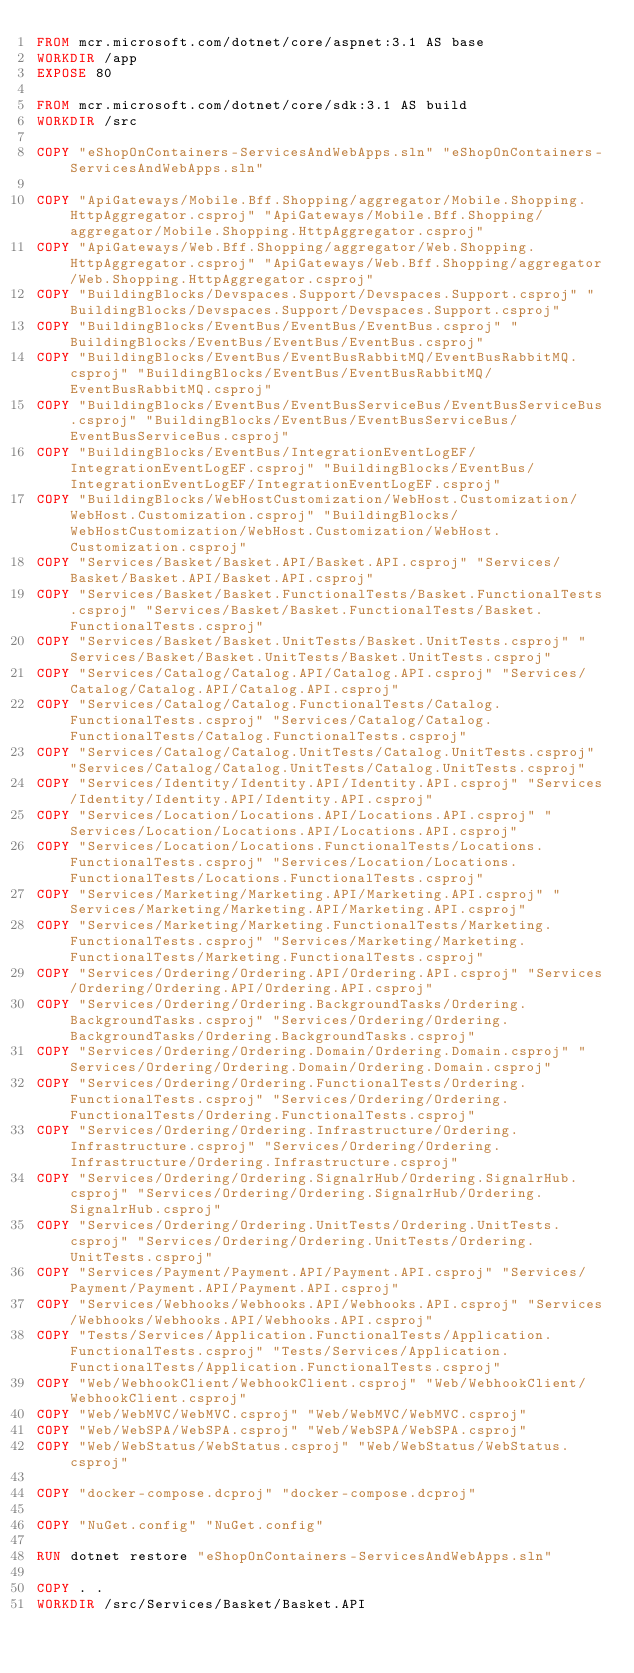Convert code to text. <code><loc_0><loc_0><loc_500><loc_500><_Dockerfile_>FROM mcr.microsoft.com/dotnet/core/aspnet:3.1 AS base
WORKDIR /app
EXPOSE 80

FROM mcr.microsoft.com/dotnet/core/sdk:3.1 AS build
WORKDIR /src

COPY "eShopOnContainers-ServicesAndWebApps.sln" "eShopOnContainers-ServicesAndWebApps.sln"

COPY "ApiGateways/Mobile.Bff.Shopping/aggregator/Mobile.Shopping.HttpAggregator.csproj" "ApiGateways/Mobile.Bff.Shopping/aggregator/Mobile.Shopping.HttpAggregator.csproj"
COPY "ApiGateways/Web.Bff.Shopping/aggregator/Web.Shopping.HttpAggregator.csproj" "ApiGateways/Web.Bff.Shopping/aggregator/Web.Shopping.HttpAggregator.csproj"
COPY "BuildingBlocks/Devspaces.Support/Devspaces.Support.csproj" "BuildingBlocks/Devspaces.Support/Devspaces.Support.csproj"
COPY "BuildingBlocks/EventBus/EventBus/EventBus.csproj" "BuildingBlocks/EventBus/EventBus/EventBus.csproj"
COPY "BuildingBlocks/EventBus/EventBusRabbitMQ/EventBusRabbitMQ.csproj" "BuildingBlocks/EventBus/EventBusRabbitMQ/EventBusRabbitMQ.csproj"
COPY "BuildingBlocks/EventBus/EventBusServiceBus/EventBusServiceBus.csproj" "BuildingBlocks/EventBus/EventBusServiceBus/EventBusServiceBus.csproj"
COPY "BuildingBlocks/EventBus/IntegrationEventLogEF/IntegrationEventLogEF.csproj" "BuildingBlocks/EventBus/IntegrationEventLogEF/IntegrationEventLogEF.csproj"
COPY "BuildingBlocks/WebHostCustomization/WebHost.Customization/WebHost.Customization.csproj" "BuildingBlocks/WebHostCustomization/WebHost.Customization/WebHost.Customization.csproj"
COPY "Services/Basket/Basket.API/Basket.API.csproj" "Services/Basket/Basket.API/Basket.API.csproj"
COPY "Services/Basket/Basket.FunctionalTests/Basket.FunctionalTests.csproj" "Services/Basket/Basket.FunctionalTests/Basket.FunctionalTests.csproj"
COPY "Services/Basket/Basket.UnitTests/Basket.UnitTests.csproj" "Services/Basket/Basket.UnitTests/Basket.UnitTests.csproj"
COPY "Services/Catalog/Catalog.API/Catalog.API.csproj" "Services/Catalog/Catalog.API/Catalog.API.csproj"
COPY "Services/Catalog/Catalog.FunctionalTests/Catalog.FunctionalTests.csproj" "Services/Catalog/Catalog.FunctionalTests/Catalog.FunctionalTests.csproj"
COPY "Services/Catalog/Catalog.UnitTests/Catalog.UnitTests.csproj" "Services/Catalog/Catalog.UnitTests/Catalog.UnitTests.csproj"
COPY "Services/Identity/Identity.API/Identity.API.csproj" "Services/Identity/Identity.API/Identity.API.csproj"
COPY "Services/Location/Locations.API/Locations.API.csproj" "Services/Location/Locations.API/Locations.API.csproj"
COPY "Services/Location/Locations.FunctionalTests/Locations.FunctionalTests.csproj" "Services/Location/Locations.FunctionalTests/Locations.FunctionalTests.csproj"
COPY "Services/Marketing/Marketing.API/Marketing.API.csproj" "Services/Marketing/Marketing.API/Marketing.API.csproj"
COPY "Services/Marketing/Marketing.FunctionalTests/Marketing.FunctionalTests.csproj" "Services/Marketing/Marketing.FunctionalTests/Marketing.FunctionalTests.csproj"
COPY "Services/Ordering/Ordering.API/Ordering.API.csproj" "Services/Ordering/Ordering.API/Ordering.API.csproj"
COPY "Services/Ordering/Ordering.BackgroundTasks/Ordering.BackgroundTasks.csproj" "Services/Ordering/Ordering.BackgroundTasks/Ordering.BackgroundTasks.csproj"
COPY "Services/Ordering/Ordering.Domain/Ordering.Domain.csproj" "Services/Ordering/Ordering.Domain/Ordering.Domain.csproj"
COPY "Services/Ordering/Ordering.FunctionalTests/Ordering.FunctionalTests.csproj" "Services/Ordering/Ordering.FunctionalTests/Ordering.FunctionalTests.csproj"
COPY "Services/Ordering/Ordering.Infrastructure/Ordering.Infrastructure.csproj" "Services/Ordering/Ordering.Infrastructure/Ordering.Infrastructure.csproj"
COPY "Services/Ordering/Ordering.SignalrHub/Ordering.SignalrHub.csproj" "Services/Ordering/Ordering.SignalrHub/Ordering.SignalrHub.csproj"
COPY "Services/Ordering/Ordering.UnitTests/Ordering.UnitTests.csproj" "Services/Ordering/Ordering.UnitTests/Ordering.UnitTests.csproj"
COPY "Services/Payment/Payment.API/Payment.API.csproj" "Services/Payment/Payment.API/Payment.API.csproj"
COPY "Services/Webhooks/Webhooks.API/Webhooks.API.csproj" "Services/Webhooks/Webhooks.API/Webhooks.API.csproj"
COPY "Tests/Services/Application.FunctionalTests/Application.FunctionalTests.csproj" "Tests/Services/Application.FunctionalTests/Application.FunctionalTests.csproj"
COPY "Web/WebhookClient/WebhookClient.csproj" "Web/WebhookClient/WebhookClient.csproj"
COPY "Web/WebMVC/WebMVC.csproj" "Web/WebMVC/WebMVC.csproj"
COPY "Web/WebSPA/WebSPA.csproj" "Web/WebSPA/WebSPA.csproj"
COPY "Web/WebStatus/WebStatus.csproj" "Web/WebStatus/WebStatus.csproj"

COPY "docker-compose.dcproj" "docker-compose.dcproj"

COPY "NuGet.config" "NuGet.config"

RUN dotnet restore "eShopOnContainers-ServicesAndWebApps.sln"

COPY . .
WORKDIR /src/Services/Basket/Basket.API</code> 